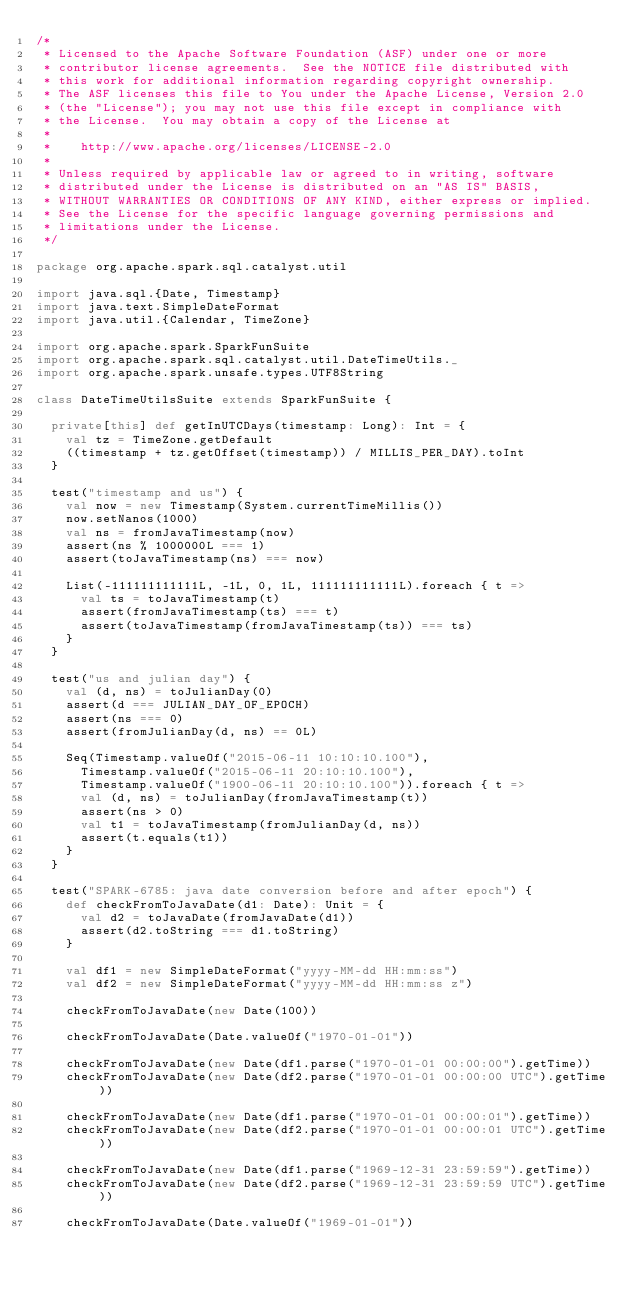<code> <loc_0><loc_0><loc_500><loc_500><_Scala_>/*
 * Licensed to the Apache Software Foundation (ASF) under one or more
 * contributor license agreements.  See the NOTICE file distributed with
 * this work for additional information regarding copyright ownership.
 * The ASF licenses this file to You under the Apache License, Version 2.0
 * (the "License"); you may not use this file except in compliance with
 * the License.  You may obtain a copy of the License at
 *
 *    http://www.apache.org/licenses/LICENSE-2.0
 *
 * Unless required by applicable law or agreed to in writing, software
 * distributed under the License is distributed on an "AS IS" BASIS,
 * WITHOUT WARRANTIES OR CONDITIONS OF ANY KIND, either express or implied.
 * See the License for the specific language governing permissions and
 * limitations under the License.
 */

package org.apache.spark.sql.catalyst.util

import java.sql.{Date, Timestamp}
import java.text.SimpleDateFormat
import java.util.{Calendar, TimeZone}

import org.apache.spark.SparkFunSuite
import org.apache.spark.sql.catalyst.util.DateTimeUtils._
import org.apache.spark.unsafe.types.UTF8String

class DateTimeUtilsSuite extends SparkFunSuite {

  private[this] def getInUTCDays(timestamp: Long): Int = {
    val tz = TimeZone.getDefault
    ((timestamp + tz.getOffset(timestamp)) / MILLIS_PER_DAY).toInt
  }

  test("timestamp and us") {
    val now = new Timestamp(System.currentTimeMillis())
    now.setNanos(1000)
    val ns = fromJavaTimestamp(now)
    assert(ns % 1000000L === 1)
    assert(toJavaTimestamp(ns) === now)

    List(-111111111111L, -1L, 0, 1L, 111111111111L).foreach { t =>
      val ts = toJavaTimestamp(t)
      assert(fromJavaTimestamp(ts) === t)
      assert(toJavaTimestamp(fromJavaTimestamp(ts)) === ts)
    }
  }

  test("us and julian day") {
    val (d, ns) = toJulianDay(0)
    assert(d === JULIAN_DAY_OF_EPOCH)
    assert(ns === 0)
    assert(fromJulianDay(d, ns) == 0L)

    Seq(Timestamp.valueOf("2015-06-11 10:10:10.100"),
      Timestamp.valueOf("2015-06-11 20:10:10.100"),
      Timestamp.valueOf("1900-06-11 20:10:10.100")).foreach { t =>
      val (d, ns) = toJulianDay(fromJavaTimestamp(t))
      assert(ns > 0)
      val t1 = toJavaTimestamp(fromJulianDay(d, ns))
      assert(t.equals(t1))
    }
  }

  test("SPARK-6785: java date conversion before and after epoch") {
    def checkFromToJavaDate(d1: Date): Unit = {
      val d2 = toJavaDate(fromJavaDate(d1))
      assert(d2.toString === d1.toString)
    }

    val df1 = new SimpleDateFormat("yyyy-MM-dd HH:mm:ss")
    val df2 = new SimpleDateFormat("yyyy-MM-dd HH:mm:ss z")

    checkFromToJavaDate(new Date(100))

    checkFromToJavaDate(Date.valueOf("1970-01-01"))

    checkFromToJavaDate(new Date(df1.parse("1970-01-01 00:00:00").getTime))
    checkFromToJavaDate(new Date(df2.parse("1970-01-01 00:00:00 UTC").getTime))

    checkFromToJavaDate(new Date(df1.parse("1970-01-01 00:00:01").getTime))
    checkFromToJavaDate(new Date(df2.parse("1970-01-01 00:00:01 UTC").getTime))

    checkFromToJavaDate(new Date(df1.parse("1969-12-31 23:59:59").getTime))
    checkFromToJavaDate(new Date(df2.parse("1969-12-31 23:59:59 UTC").getTime))

    checkFromToJavaDate(Date.valueOf("1969-01-01"))
</code> 